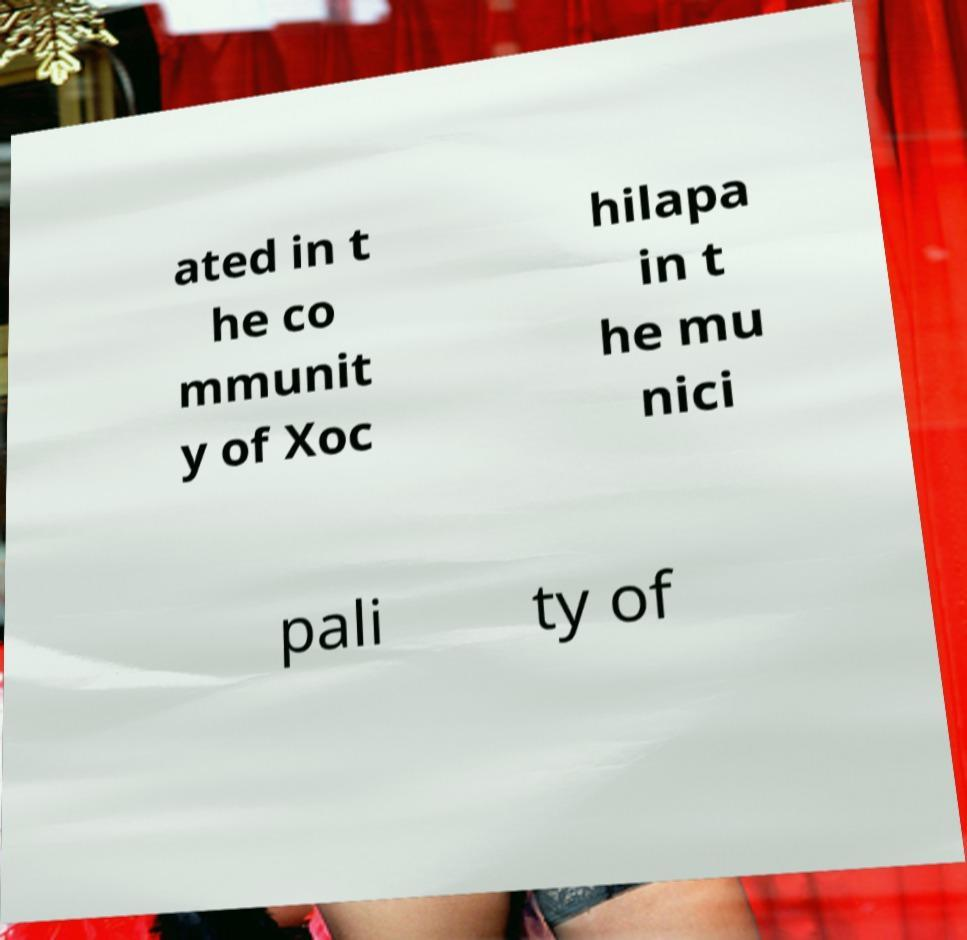What messages or text are displayed in this image? I need them in a readable, typed format. ated in t he co mmunit y of Xoc hilapa in t he mu nici pali ty of 